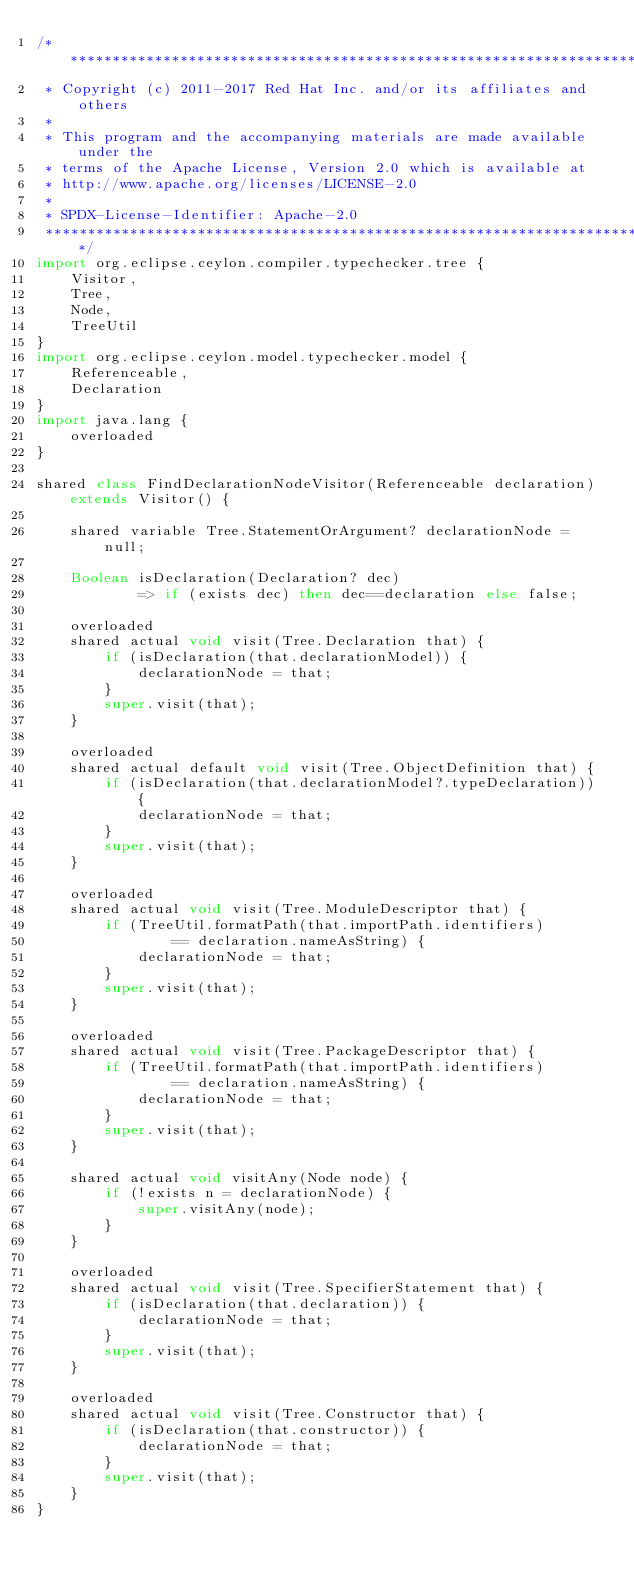Convert code to text. <code><loc_0><loc_0><loc_500><loc_500><_Ceylon_>/********************************************************************************
 * Copyright (c) 2011-2017 Red Hat Inc. and/or its affiliates and others
 *
 * This program and the accompanying materials are made available under the 
 * terms of the Apache License, Version 2.0 which is available at
 * http://www.apache.org/licenses/LICENSE-2.0
 *
 * SPDX-License-Identifier: Apache-2.0 
 ********************************************************************************/
import org.eclipse.ceylon.compiler.typechecker.tree {
    Visitor,
    Tree,
    Node,
    TreeUtil
}
import org.eclipse.ceylon.model.typechecker.model {
    Referenceable,
    Declaration
}
import java.lang {
    overloaded
}

shared class FindDeclarationNodeVisitor(Referenceable declaration) extends Visitor() {
    
    shared variable Tree.StatementOrArgument? declarationNode = null;
    
    Boolean isDeclaration(Declaration? dec) 
            => if (exists dec) then dec==declaration else false;

    overloaded
    shared actual void visit(Tree.Declaration that) {
        if (isDeclaration(that.declarationModel)) {
            declarationNode = that;
        }
        super.visit(that);
    }

    overloaded
    shared actual default void visit(Tree.ObjectDefinition that) {
        if (isDeclaration(that.declarationModel?.typeDeclaration)) {
            declarationNode = that;
        }
        super.visit(that);
    }

    overloaded
    shared actual void visit(Tree.ModuleDescriptor that) {
        if (TreeUtil.formatPath(that.importPath.identifiers)
                == declaration.nameAsString) {
            declarationNode = that;
        }
        super.visit(that);
    }

    overloaded
    shared actual void visit(Tree.PackageDescriptor that) {
        if (TreeUtil.formatPath(that.importPath.identifiers)
                == declaration.nameAsString) {
            declarationNode = that;
        }
        super.visit(that);
    }
    
    shared actual void visitAny(Node node) {
        if (!exists n = declarationNode) {
            super.visitAny(node);
        }
    }

    overloaded
    shared actual void visit(Tree.SpecifierStatement that) {
        if (isDeclaration(that.declaration)) {
            declarationNode = that;
        }
        super.visit(that);
    }

    overloaded
    shared actual void visit(Tree.Constructor that) {
        if (isDeclaration(that.constructor)) {
            declarationNode = that;
        }
        super.visit(that);
    }
}
</code> 